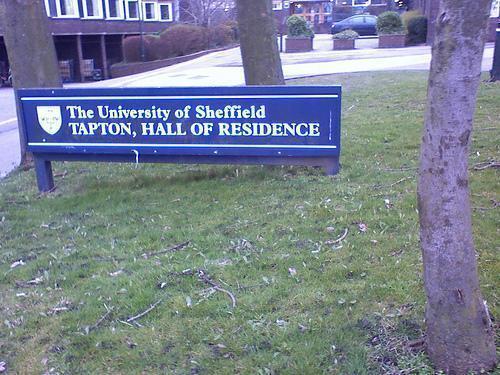Who lives in these buildings?
Pick the correct solution from the four options below to address the question.
Options: Soldiers, students, teachers, foster kids. Students. 